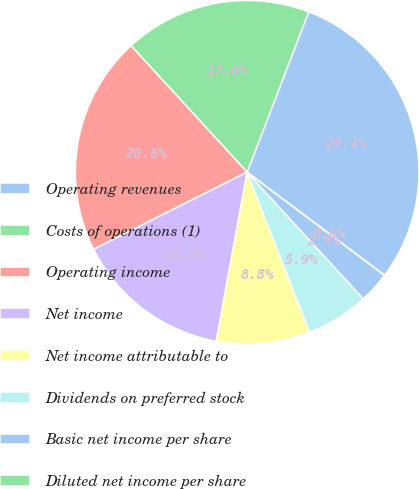Convert chart to OTSL. <chart><loc_0><loc_0><loc_500><loc_500><pie_chart><fcel>Operating revenues<fcel>Costs of operations (1)<fcel>Operating income<fcel>Net income<fcel>Net income attributable to<fcel>Dividends on preferred stock<fcel>Basic net income per share<fcel>Diluted net income per share<nl><fcel>29.41%<fcel>17.65%<fcel>20.59%<fcel>14.71%<fcel>8.82%<fcel>5.88%<fcel>2.94%<fcel>0.0%<nl></chart> 